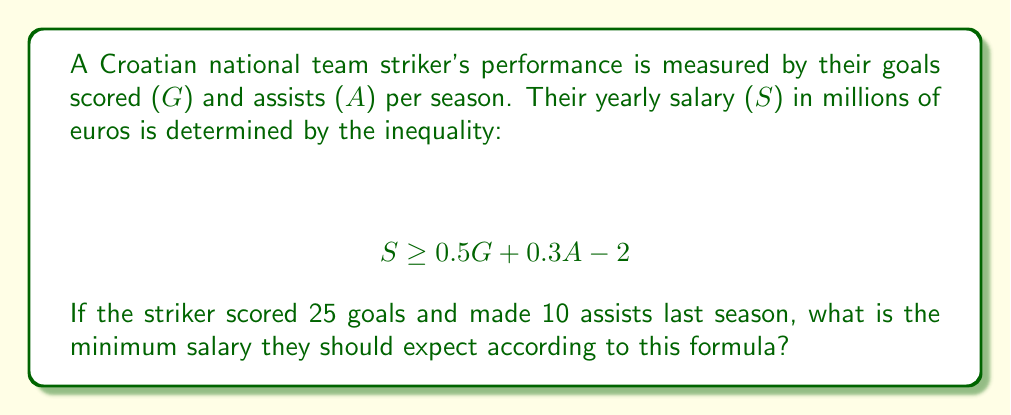Help me with this question. Let's approach this step-by-step:

1) We are given the inequality:
   $$ S \geq 0.5G + 0.3A - 2 $$

2) We know the values for G and A:
   G = 25 (goals)
   A = 10 (assists)

3) Let's substitute these values into our inequality:
   $$ S \geq 0.5(25) + 0.3(10) - 2 $$

4) Now, let's calculate the right side of the inequality:
   $$ S \geq 12.5 + 3 - 2 $$
   $$ S \geq 13.5 $$

5) The inequality sign $\geq$ means "greater than or equal to". Therefore, the minimum salary S should expect is exactly 13.5 million euros.
Answer: $13.5$ million euros 